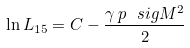Convert formula to latex. <formula><loc_0><loc_0><loc_500><loc_500>\ln L _ { 1 5 } = C - \frac { \gamma \, p \, \ s i g M ^ { 2 } } { 2 }</formula> 